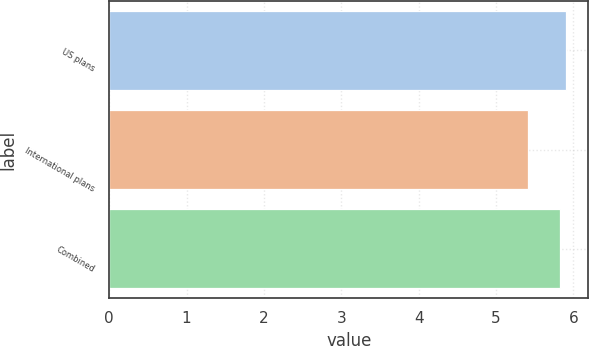<chart> <loc_0><loc_0><loc_500><loc_500><bar_chart><fcel>US plans<fcel>International plans<fcel>Combined<nl><fcel>5.9<fcel>5.41<fcel>5.83<nl></chart> 